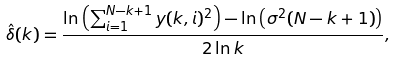<formula> <loc_0><loc_0><loc_500><loc_500>\hat { \delta } ( k ) = \frac { \ln \left ( \sum _ { i = 1 } ^ { N - k + 1 } y ( k , i ) ^ { 2 } \right ) - \ln \left ( \sigma ^ { 2 } ( N - k + 1 ) \right ) } { 2 \ln k } ,</formula> 